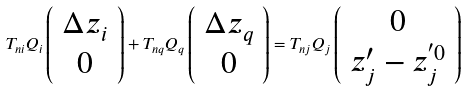Convert formula to latex. <formula><loc_0><loc_0><loc_500><loc_500>T _ { n i } Q _ { i } \left ( \begin{array} { c } \Delta z _ { i } \\ 0 \end{array} \right ) + T _ { n q } Q _ { q } \left ( \begin{array} { c } \Delta z _ { q } \\ 0 \end{array} \right ) = T _ { n j } Q _ { j } \left ( \begin{array} { c } 0 \\ z _ { j } ^ { \prime } - z _ { j } ^ { ^ { \prime } 0 } \end{array} \right )</formula> 